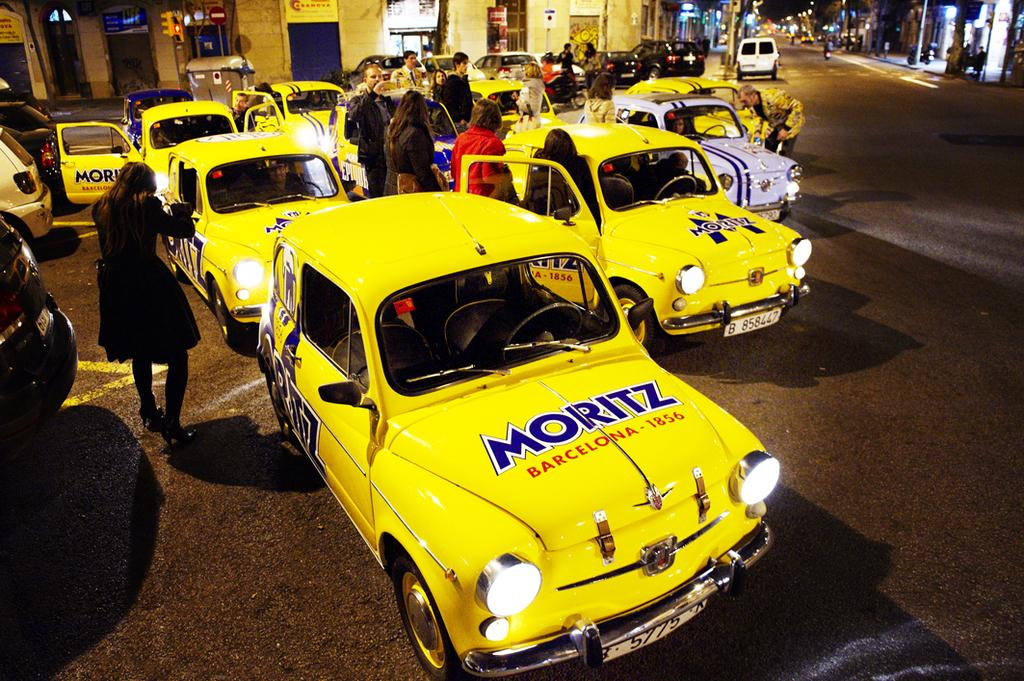<image>
Offer a succinct explanation of the picture presented. Several yellow cars with Moritz printed on their hood are parked together. 